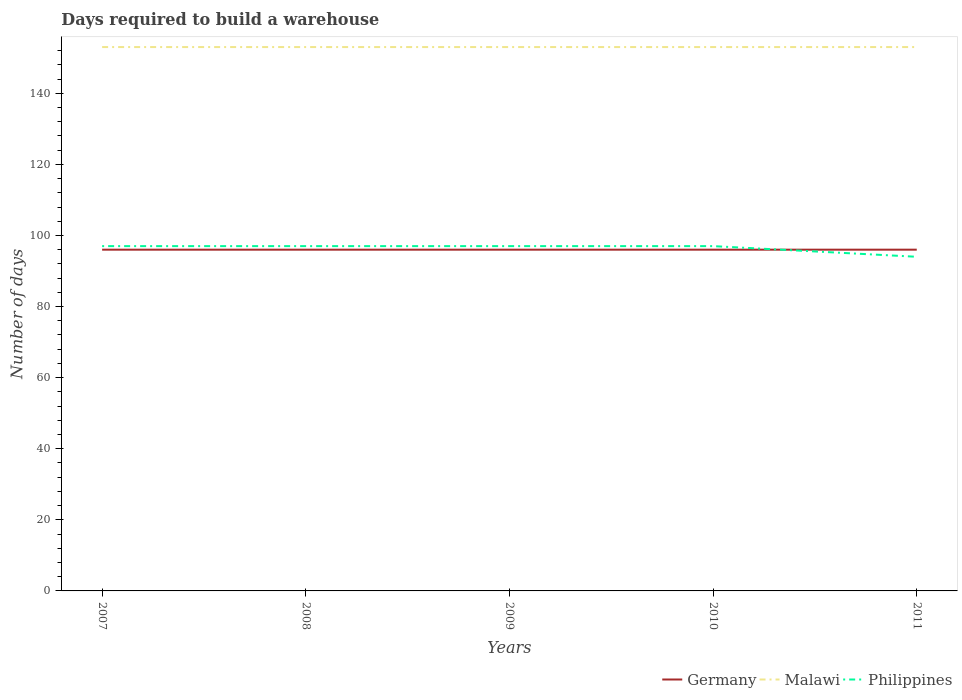How many different coloured lines are there?
Ensure brevity in your answer.  3. Is the number of lines equal to the number of legend labels?
Offer a very short reply. Yes. Across all years, what is the maximum days required to build a warehouse in in Philippines?
Your response must be concise. 94. What is the difference between the highest and the second highest days required to build a warehouse in in Malawi?
Give a very brief answer. 0. What is the difference between the highest and the lowest days required to build a warehouse in in Philippines?
Make the answer very short. 4. How many lines are there?
Make the answer very short. 3. Does the graph contain any zero values?
Your answer should be very brief. No. Does the graph contain grids?
Ensure brevity in your answer.  No. What is the title of the graph?
Provide a short and direct response. Days required to build a warehouse. Does "Eritrea" appear as one of the legend labels in the graph?
Your response must be concise. No. What is the label or title of the X-axis?
Keep it short and to the point. Years. What is the label or title of the Y-axis?
Keep it short and to the point. Number of days. What is the Number of days in Germany in 2007?
Offer a terse response. 96. What is the Number of days of Malawi in 2007?
Keep it short and to the point. 153. What is the Number of days of Philippines in 2007?
Provide a short and direct response. 97. What is the Number of days of Germany in 2008?
Make the answer very short. 96. What is the Number of days of Malawi in 2008?
Your answer should be compact. 153. What is the Number of days of Philippines in 2008?
Keep it short and to the point. 97. What is the Number of days in Germany in 2009?
Your response must be concise. 96. What is the Number of days in Malawi in 2009?
Offer a very short reply. 153. What is the Number of days of Philippines in 2009?
Make the answer very short. 97. What is the Number of days of Germany in 2010?
Make the answer very short. 96. What is the Number of days in Malawi in 2010?
Ensure brevity in your answer.  153. What is the Number of days in Philippines in 2010?
Ensure brevity in your answer.  97. What is the Number of days of Germany in 2011?
Your response must be concise. 96. What is the Number of days in Malawi in 2011?
Your answer should be compact. 153. What is the Number of days in Philippines in 2011?
Your answer should be very brief. 94. Across all years, what is the maximum Number of days in Germany?
Offer a very short reply. 96. Across all years, what is the maximum Number of days of Malawi?
Your response must be concise. 153. Across all years, what is the maximum Number of days of Philippines?
Offer a very short reply. 97. Across all years, what is the minimum Number of days of Germany?
Ensure brevity in your answer.  96. Across all years, what is the minimum Number of days in Malawi?
Ensure brevity in your answer.  153. Across all years, what is the minimum Number of days of Philippines?
Your response must be concise. 94. What is the total Number of days of Germany in the graph?
Provide a succinct answer. 480. What is the total Number of days in Malawi in the graph?
Your answer should be compact. 765. What is the total Number of days in Philippines in the graph?
Offer a terse response. 482. What is the difference between the Number of days of Germany in 2007 and that in 2008?
Your answer should be compact. 0. What is the difference between the Number of days of Germany in 2007 and that in 2009?
Offer a very short reply. 0. What is the difference between the Number of days of Malawi in 2007 and that in 2009?
Ensure brevity in your answer.  0. What is the difference between the Number of days of Philippines in 2007 and that in 2009?
Keep it short and to the point. 0. What is the difference between the Number of days of Germany in 2007 and that in 2010?
Offer a very short reply. 0. What is the difference between the Number of days in Philippines in 2007 and that in 2010?
Provide a succinct answer. 0. What is the difference between the Number of days in Germany in 2007 and that in 2011?
Your answer should be compact. 0. What is the difference between the Number of days in Malawi in 2007 and that in 2011?
Provide a succinct answer. 0. What is the difference between the Number of days in Philippines in 2007 and that in 2011?
Provide a succinct answer. 3. What is the difference between the Number of days of Germany in 2008 and that in 2009?
Keep it short and to the point. 0. What is the difference between the Number of days in Malawi in 2008 and that in 2009?
Your response must be concise. 0. What is the difference between the Number of days in Philippines in 2008 and that in 2009?
Make the answer very short. 0. What is the difference between the Number of days in Philippines in 2008 and that in 2010?
Offer a very short reply. 0. What is the difference between the Number of days of Germany in 2008 and that in 2011?
Your answer should be very brief. 0. What is the difference between the Number of days of Malawi in 2008 and that in 2011?
Ensure brevity in your answer.  0. What is the difference between the Number of days of Philippines in 2008 and that in 2011?
Offer a very short reply. 3. What is the difference between the Number of days in Malawi in 2009 and that in 2010?
Provide a short and direct response. 0. What is the difference between the Number of days of Philippines in 2009 and that in 2010?
Your answer should be very brief. 0. What is the difference between the Number of days of Germany in 2009 and that in 2011?
Your answer should be very brief. 0. What is the difference between the Number of days in Philippines in 2009 and that in 2011?
Offer a terse response. 3. What is the difference between the Number of days of Germany in 2010 and that in 2011?
Offer a terse response. 0. What is the difference between the Number of days in Malawi in 2010 and that in 2011?
Your response must be concise. 0. What is the difference between the Number of days in Germany in 2007 and the Number of days in Malawi in 2008?
Make the answer very short. -57. What is the difference between the Number of days of Germany in 2007 and the Number of days of Philippines in 2008?
Offer a terse response. -1. What is the difference between the Number of days in Malawi in 2007 and the Number of days in Philippines in 2008?
Ensure brevity in your answer.  56. What is the difference between the Number of days of Germany in 2007 and the Number of days of Malawi in 2009?
Keep it short and to the point. -57. What is the difference between the Number of days in Malawi in 2007 and the Number of days in Philippines in 2009?
Offer a terse response. 56. What is the difference between the Number of days in Germany in 2007 and the Number of days in Malawi in 2010?
Offer a terse response. -57. What is the difference between the Number of days in Malawi in 2007 and the Number of days in Philippines in 2010?
Offer a very short reply. 56. What is the difference between the Number of days of Germany in 2007 and the Number of days of Malawi in 2011?
Offer a terse response. -57. What is the difference between the Number of days of Germany in 2008 and the Number of days of Malawi in 2009?
Provide a succinct answer. -57. What is the difference between the Number of days of Germany in 2008 and the Number of days of Philippines in 2009?
Provide a succinct answer. -1. What is the difference between the Number of days of Malawi in 2008 and the Number of days of Philippines in 2009?
Offer a very short reply. 56. What is the difference between the Number of days of Germany in 2008 and the Number of days of Malawi in 2010?
Make the answer very short. -57. What is the difference between the Number of days of Germany in 2008 and the Number of days of Malawi in 2011?
Ensure brevity in your answer.  -57. What is the difference between the Number of days of Malawi in 2008 and the Number of days of Philippines in 2011?
Ensure brevity in your answer.  59. What is the difference between the Number of days of Germany in 2009 and the Number of days of Malawi in 2010?
Ensure brevity in your answer.  -57. What is the difference between the Number of days of Germany in 2009 and the Number of days of Philippines in 2010?
Your response must be concise. -1. What is the difference between the Number of days in Germany in 2009 and the Number of days in Malawi in 2011?
Provide a short and direct response. -57. What is the difference between the Number of days in Germany in 2009 and the Number of days in Philippines in 2011?
Provide a short and direct response. 2. What is the difference between the Number of days of Germany in 2010 and the Number of days of Malawi in 2011?
Keep it short and to the point. -57. What is the average Number of days of Germany per year?
Your answer should be compact. 96. What is the average Number of days of Malawi per year?
Ensure brevity in your answer.  153. What is the average Number of days of Philippines per year?
Give a very brief answer. 96.4. In the year 2007, what is the difference between the Number of days of Germany and Number of days of Malawi?
Your response must be concise. -57. In the year 2008, what is the difference between the Number of days of Germany and Number of days of Malawi?
Your answer should be very brief. -57. In the year 2009, what is the difference between the Number of days in Germany and Number of days in Malawi?
Your answer should be very brief. -57. In the year 2010, what is the difference between the Number of days in Germany and Number of days in Malawi?
Offer a terse response. -57. In the year 2010, what is the difference between the Number of days in Malawi and Number of days in Philippines?
Your answer should be very brief. 56. In the year 2011, what is the difference between the Number of days of Germany and Number of days of Malawi?
Your response must be concise. -57. What is the ratio of the Number of days of Philippines in 2007 to that in 2008?
Make the answer very short. 1. What is the ratio of the Number of days in Malawi in 2007 to that in 2009?
Keep it short and to the point. 1. What is the ratio of the Number of days in Philippines in 2007 to that in 2010?
Keep it short and to the point. 1. What is the ratio of the Number of days in Germany in 2007 to that in 2011?
Provide a succinct answer. 1. What is the ratio of the Number of days of Malawi in 2007 to that in 2011?
Offer a very short reply. 1. What is the ratio of the Number of days of Philippines in 2007 to that in 2011?
Make the answer very short. 1.03. What is the ratio of the Number of days of Germany in 2008 to that in 2010?
Offer a very short reply. 1. What is the ratio of the Number of days in Philippines in 2008 to that in 2010?
Provide a short and direct response. 1. What is the ratio of the Number of days of Germany in 2008 to that in 2011?
Give a very brief answer. 1. What is the ratio of the Number of days in Malawi in 2008 to that in 2011?
Give a very brief answer. 1. What is the ratio of the Number of days of Philippines in 2008 to that in 2011?
Your answer should be very brief. 1.03. What is the ratio of the Number of days of Malawi in 2009 to that in 2011?
Your answer should be very brief. 1. What is the ratio of the Number of days in Philippines in 2009 to that in 2011?
Make the answer very short. 1.03. What is the ratio of the Number of days of Germany in 2010 to that in 2011?
Provide a succinct answer. 1. What is the ratio of the Number of days in Malawi in 2010 to that in 2011?
Provide a short and direct response. 1. What is the ratio of the Number of days in Philippines in 2010 to that in 2011?
Provide a short and direct response. 1.03. What is the difference between the highest and the second highest Number of days of Germany?
Your answer should be compact. 0. What is the difference between the highest and the lowest Number of days in Malawi?
Provide a succinct answer. 0. 